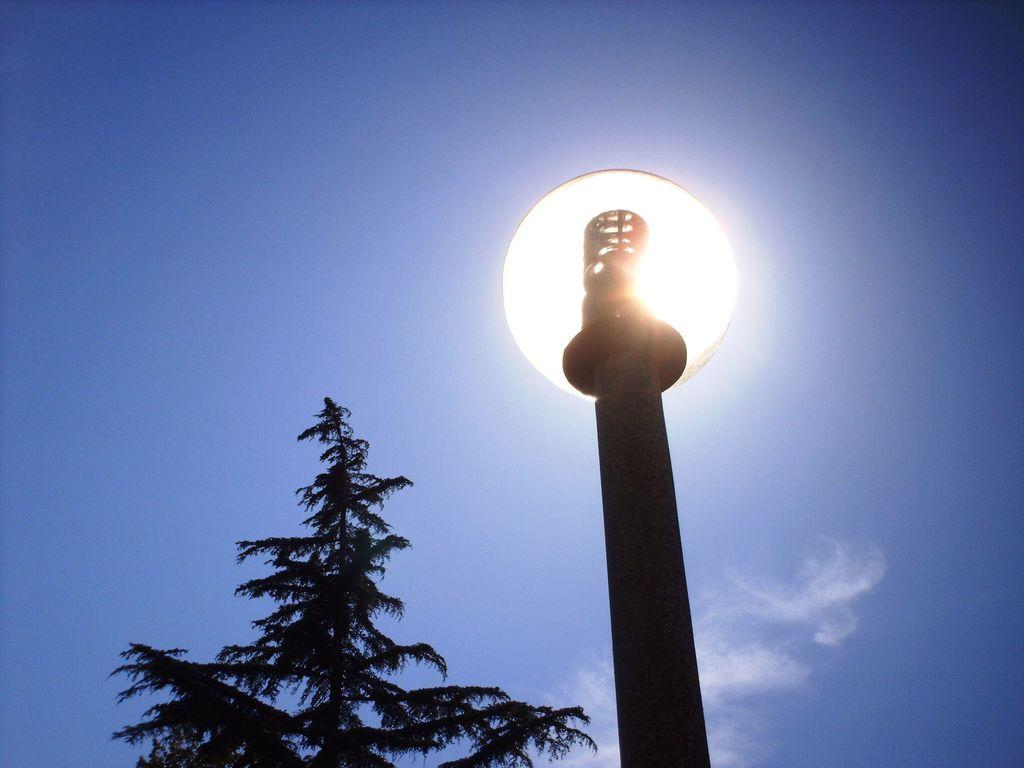What is the color of the lamppost in the image? The lamppost in the image is black. What is located near the lamppost? There is a tree beside the lamppost. What can be seen in the background of the image? The sky is visible in the background of the image. How many shades of waste can be seen in the image? There is no waste present in the image, so it is not possible to determine the number of shades. 